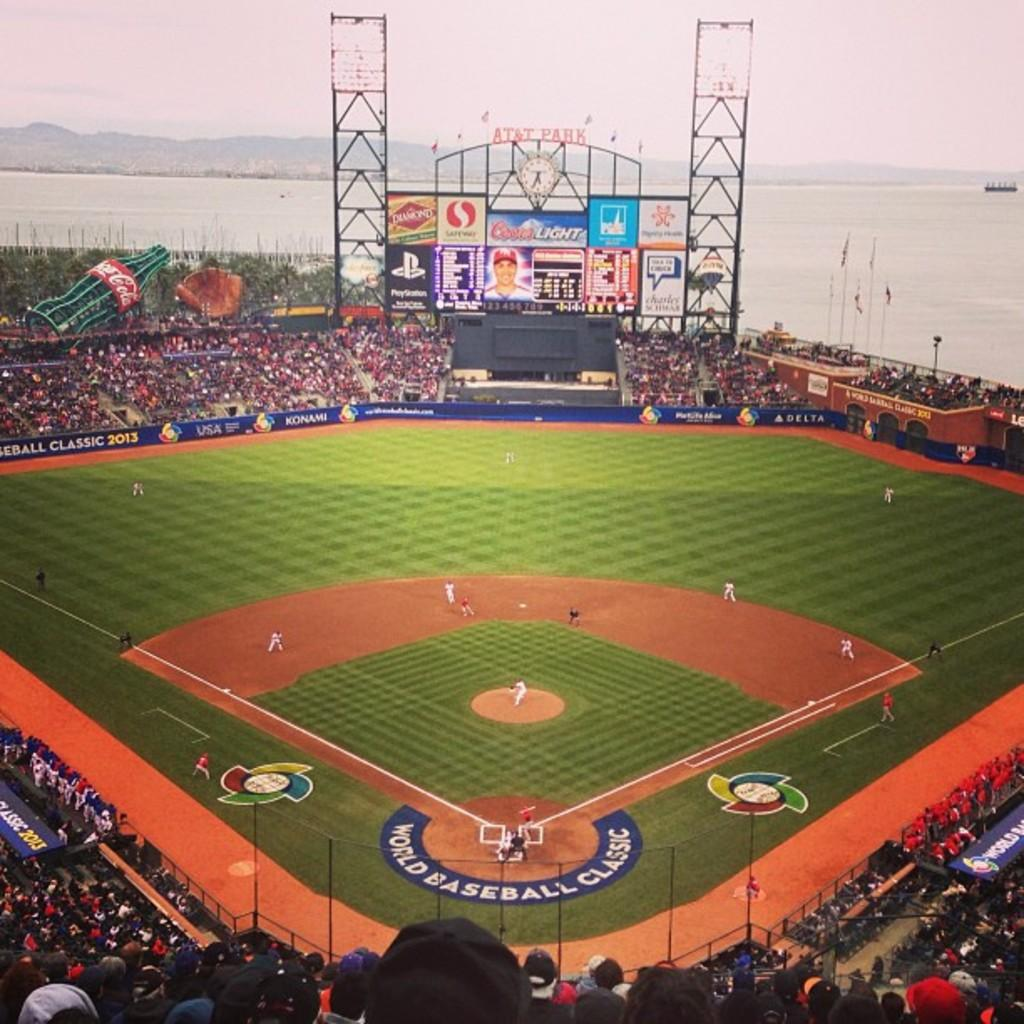<image>
Relay a brief, clear account of the picture shown. The ad on the billboard is for the grocery store Safeway 